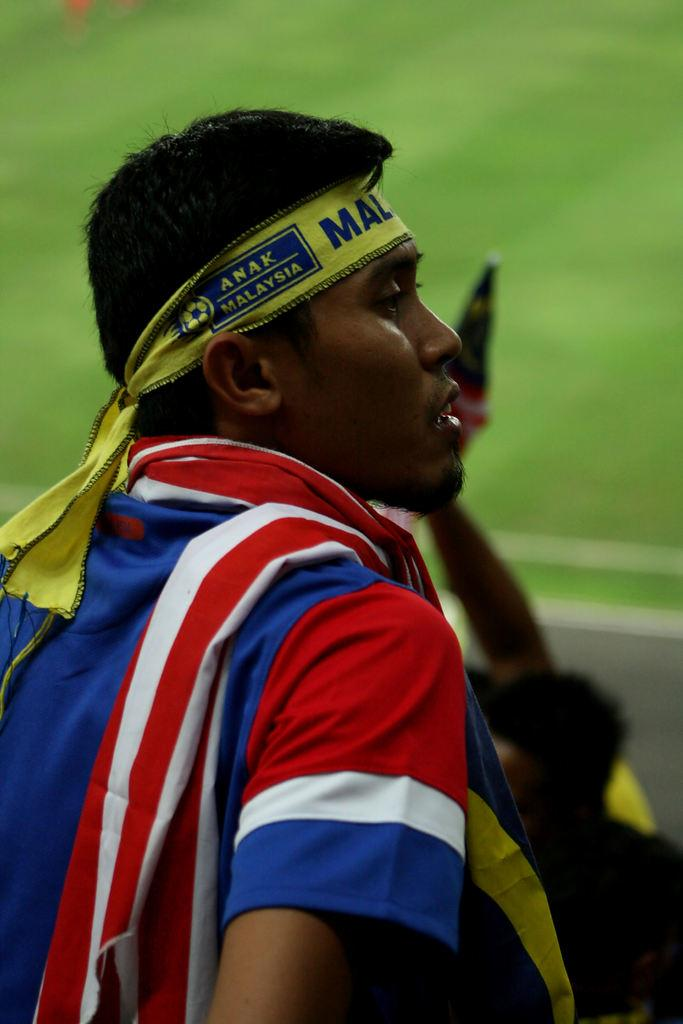<image>
Relay a brief, clear account of the picture shown. A man wearing an Anak Malaysia brand headband. 